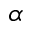<formula> <loc_0><loc_0><loc_500><loc_500>\alpha</formula> 